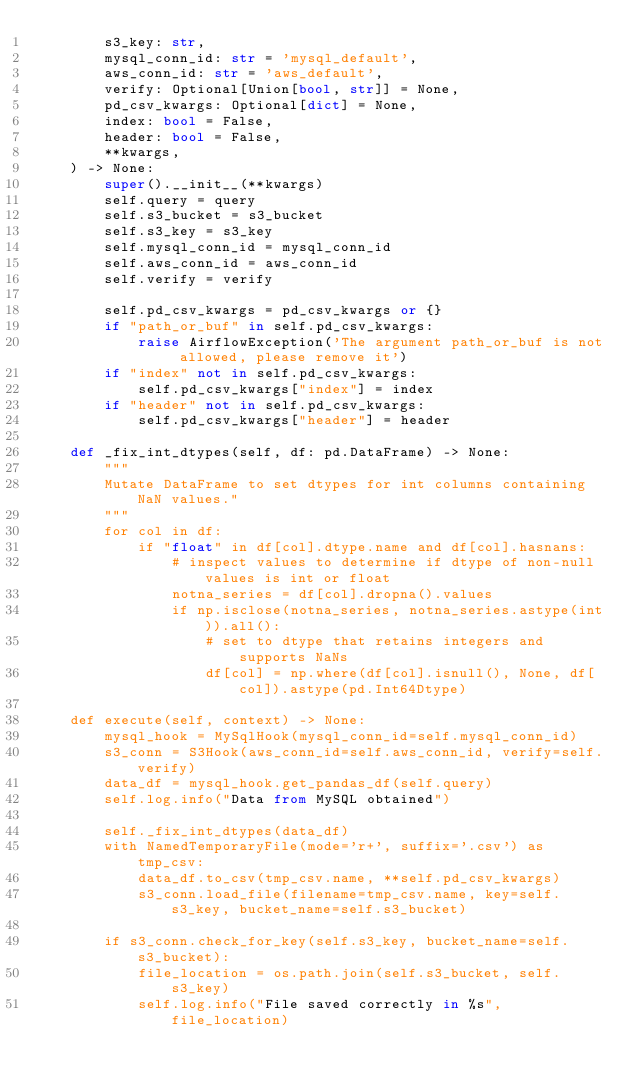<code> <loc_0><loc_0><loc_500><loc_500><_Python_>        s3_key: str,
        mysql_conn_id: str = 'mysql_default',
        aws_conn_id: str = 'aws_default',
        verify: Optional[Union[bool, str]] = None,
        pd_csv_kwargs: Optional[dict] = None,
        index: bool = False,
        header: bool = False,
        **kwargs,
    ) -> None:
        super().__init__(**kwargs)
        self.query = query
        self.s3_bucket = s3_bucket
        self.s3_key = s3_key
        self.mysql_conn_id = mysql_conn_id
        self.aws_conn_id = aws_conn_id
        self.verify = verify

        self.pd_csv_kwargs = pd_csv_kwargs or {}
        if "path_or_buf" in self.pd_csv_kwargs:
            raise AirflowException('The argument path_or_buf is not allowed, please remove it')
        if "index" not in self.pd_csv_kwargs:
            self.pd_csv_kwargs["index"] = index
        if "header" not in self.pd_csv_kwargs:
            self.pd_csv_kwargs["header"] = header

    def _fix_int_dtypes(self, df: pd.DataFrame) -> None:
        """
        Mutate DataFrame to set dtypes for int columns containing NaN values."
        """
        for col in df:
            if "float" in df[col].dtype.name and df[col].hasnans:
                # inspect values to determine if dtype of non-null values is int or float
                notna_series = df[col].dropna().values
                if np.isclose(notna_series, notna_series.astype(int)).all():
                    # set to dtype that retains integers and supports NaNs
                    df[col] = np.where(df[col].isnull(), None, df[col]).astype(pd.Int64Dtype)

    def execute(self, context) -> None:
        mysql_hook = MySqlHook(mysql_conn_id=self.mysql_conn_id)
        s3_conn = S3Hook(aws_conn_id=self.aws_conn_id, verify=self.verify)
        data_df = mysql_hook.get_pandas_df(self.query)
        self.log.info("Data from MySQL obtained")

        self._fix_int_dtypes(data_df)
        with NamedTemporaryFile(mode='r+', suffix='.csv') as tmp_csv:
            data_df.to_csv(tmp_csv.name, **self.pd_csv_kwargs)
            s3_conn.load_file(filename=tmp_csv.name, key=self.s3_key, bucket_name=self.s3_bucket)

        if s3_conn.check_for_key(self.s3_key, bucket_name=self.s3_bucket):
            file_location = os.path.join(self.s3_bucket, self.s3_key)
            self.log.info("File saved correctly in %s", file_location)
</code> 